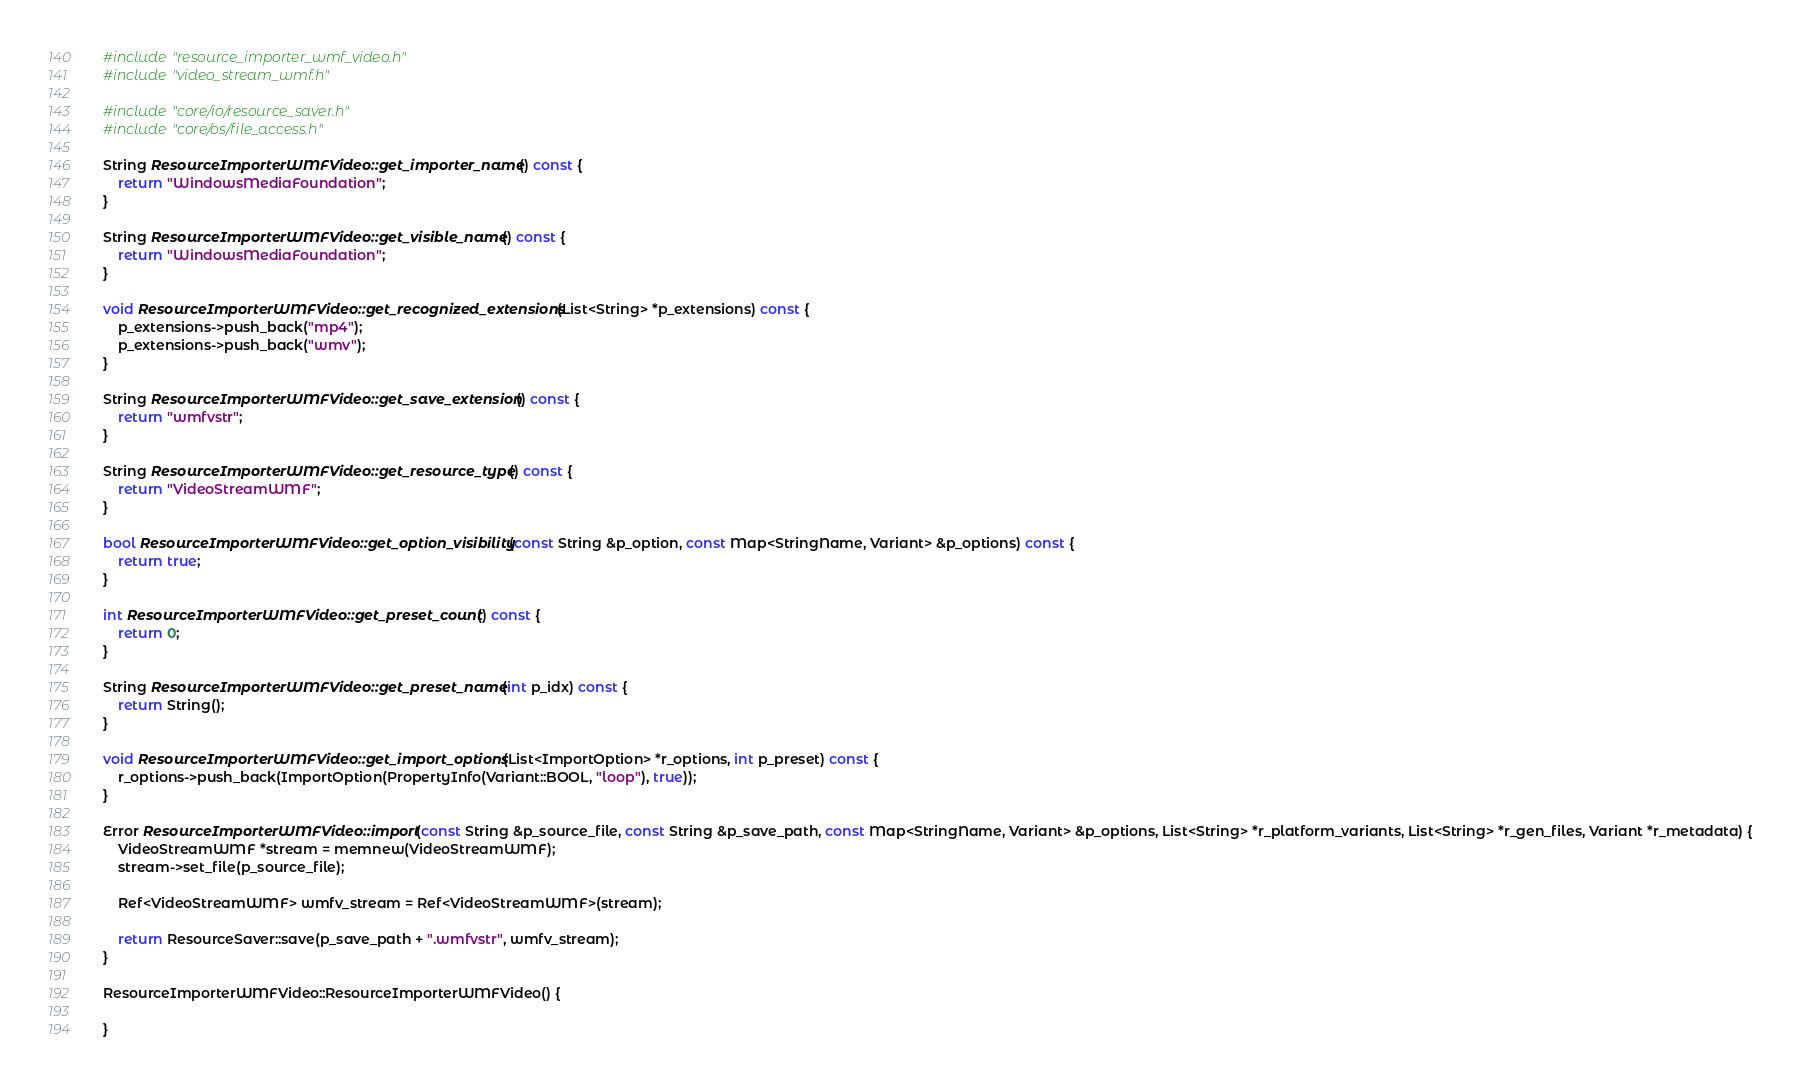Convert code to text. <code><loc_0><loc_0><loc_500><loc_500><_C++_>#include "resource_importer_wmf_video.h"
#include "video_stream_wmf.h"

#include "core/io/resource_saver.h"
#include "core/os/file_access.h"

String ResourceImporterWMFVideo::get_importer_name() const {
    return "WindowsMediaFoundation";
}

String ResourceImporterWMFVideo::get_visible_name() const {
    return "WindowsMediaFoundation";
}

void ResourceImporterWMFVideo::get_recognized_extensions(List<String> *p_extensions) const {
    p_extensions->push_back("mp4");
	p_extensions->push_back("wmv");
}

String ResourceImporterWMFVideo::get_save_extension() const {
    return "wmfvstr";
}

String ResourceImporterWMFVideo::get_resource_type() const {
    return "VideoStreamWMF";
}

bool ResourceImporterWMFVideo::get_option_visibility(const String &p_option, const Map<StringName, Variant> &p_options) const {
    return true;
}

int ResourceImporterWMFVideo::get_preset_count() const {
    return 0;
}

String ResourceImporterWMFVideo::get_preset_name(int p_idx) const {
    return String();
}

void ResourceImporterWMFVideo::get_import_options(List<ImportOption> *r_options, int p_preset) const {
    r_options->push_back(ImportOption(PropertyInfo(Variant::BOOL, "loop"), true));
}

Error ResourceImporterWMFVideo::import(const String &p_source_file, const String &p_save_path, const Map<StringName, Variant> &p_options, List<String> *r_platform_variants, List<String> *r_gen_files, Variant *r_metadata) {
    VideoStreamWMF *stream = memnew(VideoStreamWMF);
    stream->set_file(p_source_file);

    Ref<VideoStreamWMF> wmfv_stream = Ref<VideoStreamWMF>(stream);

    return ResourceSaver::save(p_save_path + ".wmfvstr", wmfv_stream);
}

ResourceImporterWMFVideo::ResourceImporterWMFVideo() {

}
</code> 